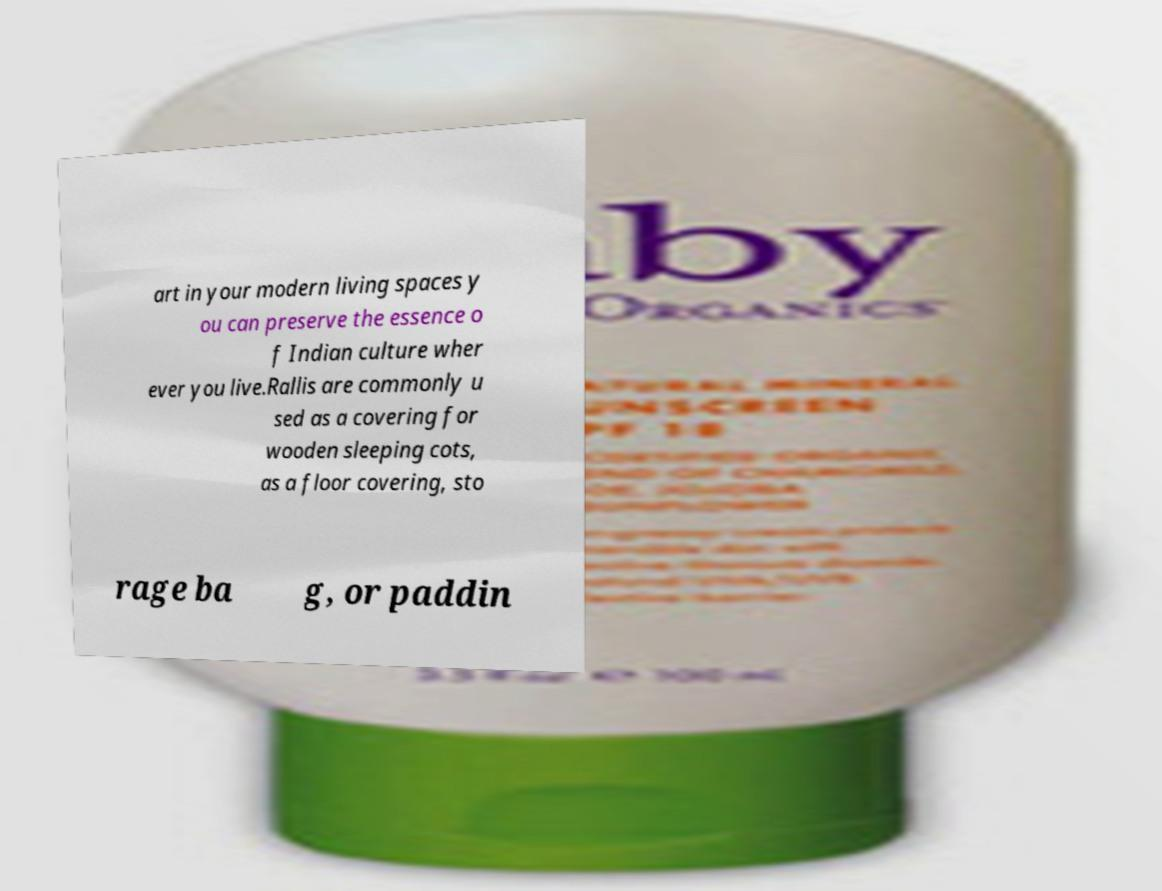Could you extract and type out the text from this image? art in your modern living spaces y ou can preserve the essence o f Indian culture wher ever you live.Rallis are commonly u sed as a covering for wooden sleeping cots, as a floor covering, sto rage ba g, or paddin 